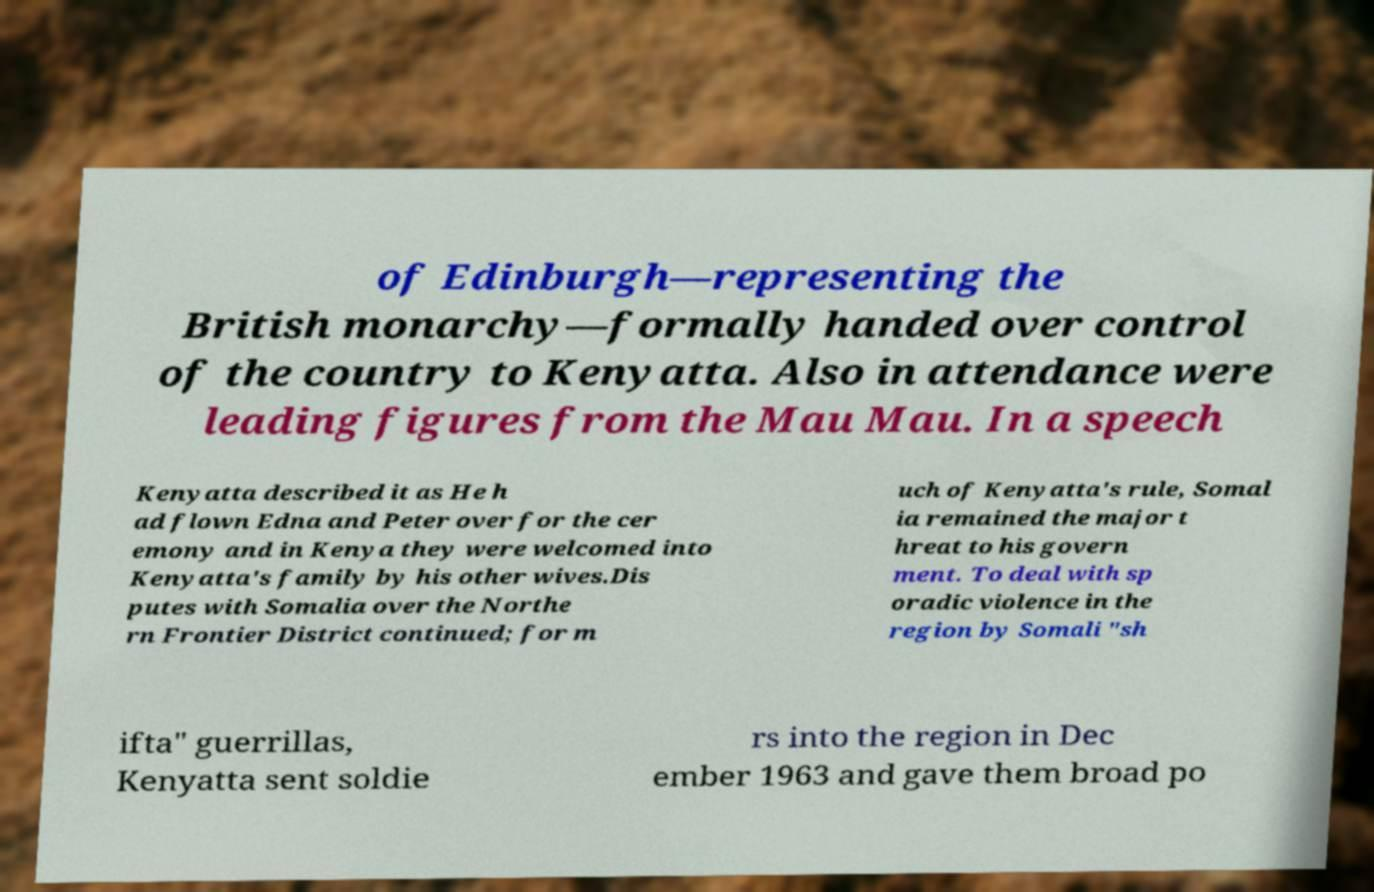For documentation purposes, I need the text within this image transcribed. Could you provide that? of Edinburgh—representing the British monarchy—formally handed over control of the country to Kenyatta. Also in attendance were leading figures from the Mau Mau. In a speech Kenyatta described it as He h ad flown Edna and Peter over for the cer emony and in Kenya they were welcomed into Kenyatta's family by his other wives.Dis putes with Somalia over the Northe rn Frontier District continued; for m uch of Kenyatta's rule, Somal ia remained the major t hreat to his govern ment. To deal with sp oradic violence in the region by Somali "sh ifta" guerrillas, Kenyatta sent soldie rs into the region in Dec ember 1963 and gave them broad po 